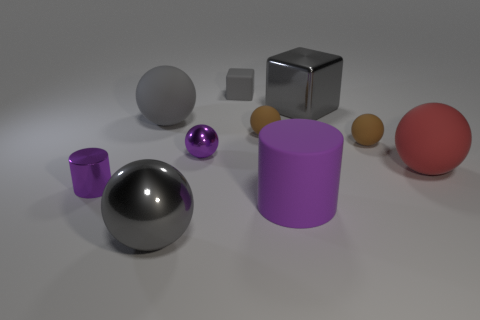There is a large object that is both in front of the small purple cylinder and on the right side of the small gray rubber object; what is its shape?
Your answer should be compact. Cylinder. What material is the purple ball?
Provide a short and direct response. Metal. How many spheres are either big purple matte things or small gray objects?
Offer a terse response. 0. Is the tiny gray thing made of the same material as the large red object?
Your response must be concise. Yes. There is a gray metallic object that is the same shape as the large red object; what size is it?
Offer a very short reply. Large. What is the large gray thing that is both on the right side of the large gray rubber thing and on the left side of the large gray block made of?
Your response must be concise. Metal. Is the number of tiny brown things on the left side of the tiny rubber block the same as the number of big rubber balls?
Make the answer very short. No. How many objects are matte spheres behind the big cylinder or small gray cylinders?
Your answer should be very brief. 4. Does the large rubber sphere that is to the left of the big gray metal cube have the same color as the large metallic sphere?
Make the answer very short. Yes. What size is the block to the right of the large purple rubber cylinder?
Offer a terse response. Large. 